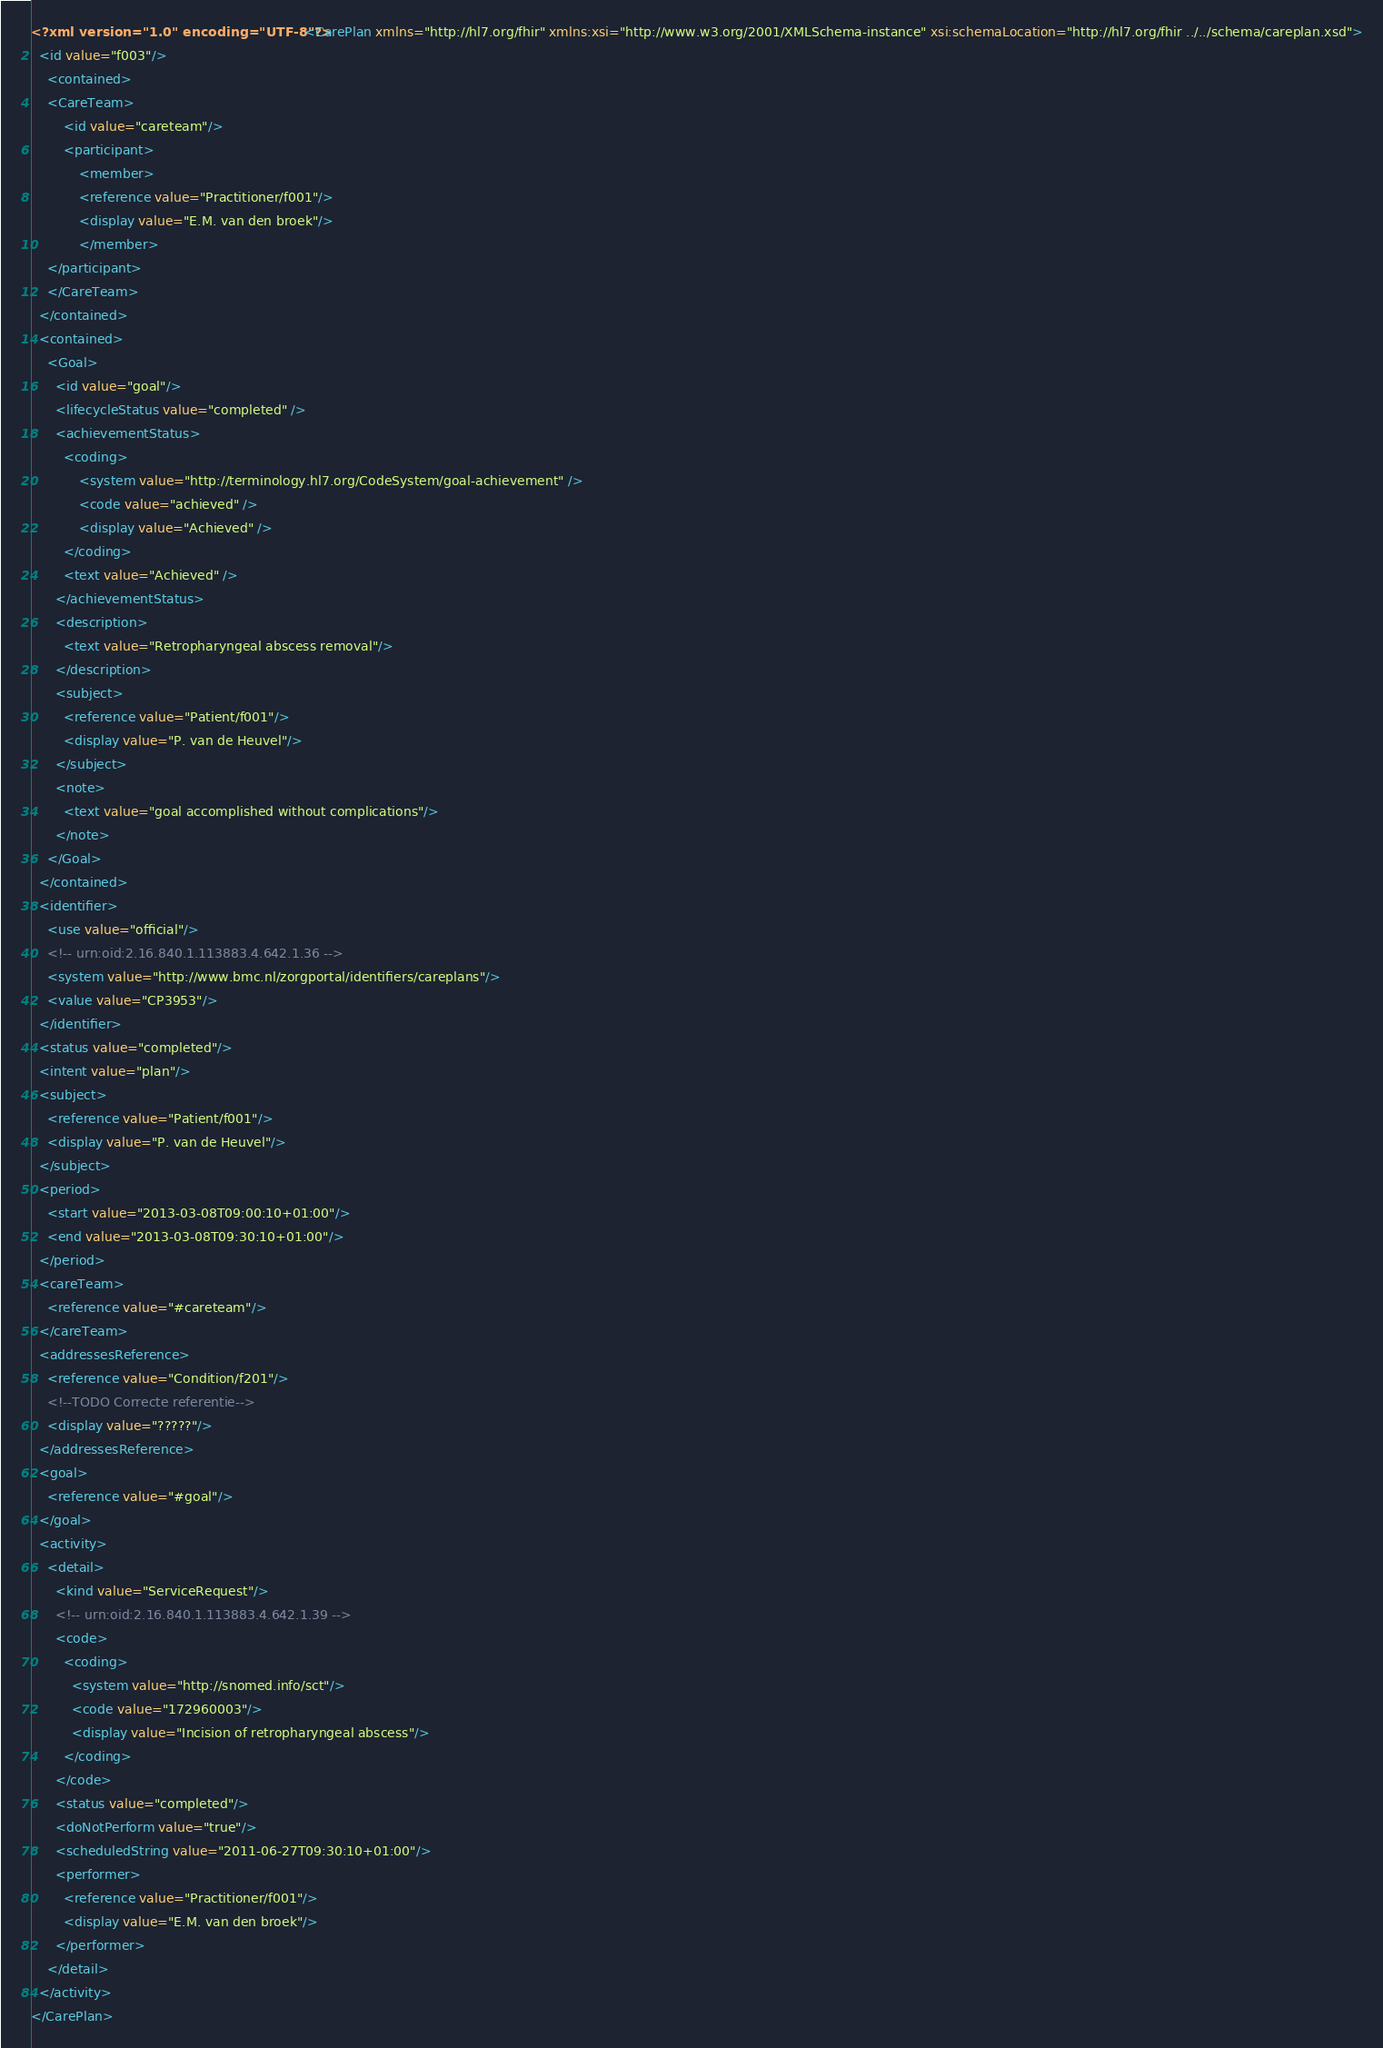<code> <loc_0><loc_0><loc_500><loc_500><_XML_><?xml version="1.0" encoding="UTF-8"?><CarePlan xmlns="http://hl7.org/fhir" xmlns:xsi="http://www.w3.org/2001/XMLSchema-instance" xsi:schemaLocation="http://hl7.org/fhir ../../schema/careplan.xsd">
  <id value="f003"/>
    <contained>
    <CareTeam>
        <id value="careteam"/>
        <participant>
    	    <member>
      		<reference value="Practitioner/f001"/>
      		<display value="E.M. van den broek"/>
    	    </member>
  	</participant>
    </CareTeam>
  </contained>
  <contained>
    <Goal>
      <id value="goal"/>
      <lifecycleStatus value="completed" />
	  <achievementStatus>
		<coding>
			<system value="http://terminology.hl7.org/CodeSystem/goal-achievement" />
			<code value="achieved" />
			<display value="Achieved" />
		</coding>
		<text value="Achieved" />
	  </achievementStatus>
      <description>
        <text value="Retropharyngeal abscess removal"/>
      </description>
      <subject>
        <reference value="Patient/f001"/>
        <display value="P. van de Heuvel"/>
      </subject>     
      <note>
        <text value="goal accomplished without complications"/> 
      </note>
    </Goal>
  </contained>
  <identifier>
    <use value="official"/>
    <!-- urn:oid:2.16.840.1.113883.4.642.1.36 -->
    <system value="http://www.bmc.nl/zorgportal/identifiers/careplans"/>
    <value value="CP3953"/>
  </identifier>
  <status value="completed"/>
  <intent value="plan"/>
  <subject>
    <reference value="Patient/f001"/>
    <display value="P. van de Heuvel"/>
  </subject>
  <period>
    <start value="2013-03-08T09:00:10+01:00"/>
    <end value="2013-03-08T09:30:10+01:00"/>
  </period>
  <careTeam>
    <reference value="#careteam"/>
  </careTeam>
  <addressesReference>
    <reference value="Condition/f201"/>
    <!--TODO Correcte referentie-->
    <display value="?????"/>
  </addressesReference>
  <goal>
    <reference value="#goal"/>
  </goal>
  <activity>
    <detail>
      <kind value="ServiceRequest"/>
      <!-- urn:oid:2.16.840.1.113883.4.642.1.39 -->
      <code>
        <coding>
          <system value="http://snomed.info/sct"/>
          <code value="172960003"/>
          <display value="Incision of retropharyngeal abscess"/>
        </coding>
      </code>
      <status value="completed"/>
      <doNotPerform value="true"/>
      <scheduledString value="2011-06-27T09:30:10+01:00"/>
      <performer>
        <reference value="Practitioner/f001"/>
        <display value="E.M. van den broek"/>
      </performer>
    </detail>
  </activity>
</CarePlan></code> 